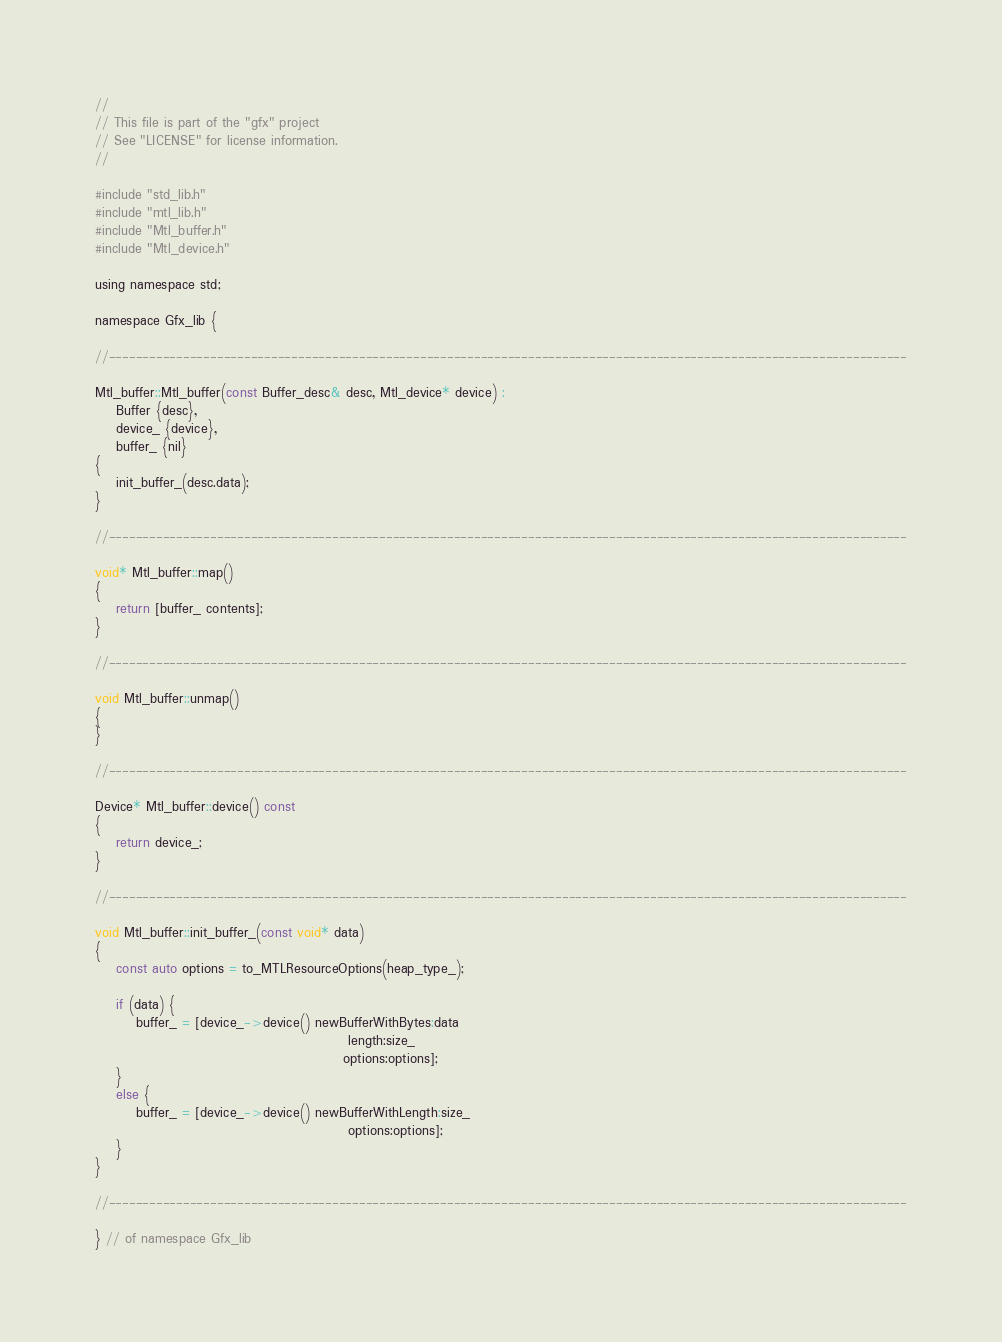<code> <loc_0><loc_0><loc_500><loc_500><_ObjectiveC_>//
// This file is part of the "gfx" project
// See "LICENSE" for license information.
//

#include "std_lib.h"
#include "mtl_lib.h"
#include "Mtl_buffer.h"
#include "Mtl_device.h"

using namespace std;

namespace Gfx_lib {

//----------------------------------------------------------------------------------------------------------------------

Mtl_buffer::Mtl_buffer(const Buffer_desc& desc, Mtl_device* device) :
    Buffer {desc},
    device_ {device},
    buffer_ {nil}
{
    init_buffer_(desc.data);
}

//----------------------------------------------------------------------------------------------------------------------

void* Mtl_buffer::map()
{
    return [buffer_ contents];
}

//----------------------------------------------------------------------------------------------------------------------

void Mtl_buffer::unmap()
{
}

//----------------------------------------------------------------------------------------------------------------------

Device* Mtl_buffer::device() const
{
    return device_;
}

//----------------------------------------------------------------------------------------------------------------------

void Mtl_buffer::init_buffer_(const void* data)
{
    const auto options = to_MTLResourceOptions(heap_type_);

    if (data) {
        buffer_ = [device_->device() newBufferWithBytes:data
                                                 length:size_
                                                options:options];
    }
    else {
        buffer_ = [device_->device() newBufferWithLength:size_
                                                 options:options];
    }
}

//----------------------------------------------------------------------------------------------------------------------

} // of namespace Gfx_lib
</code> 